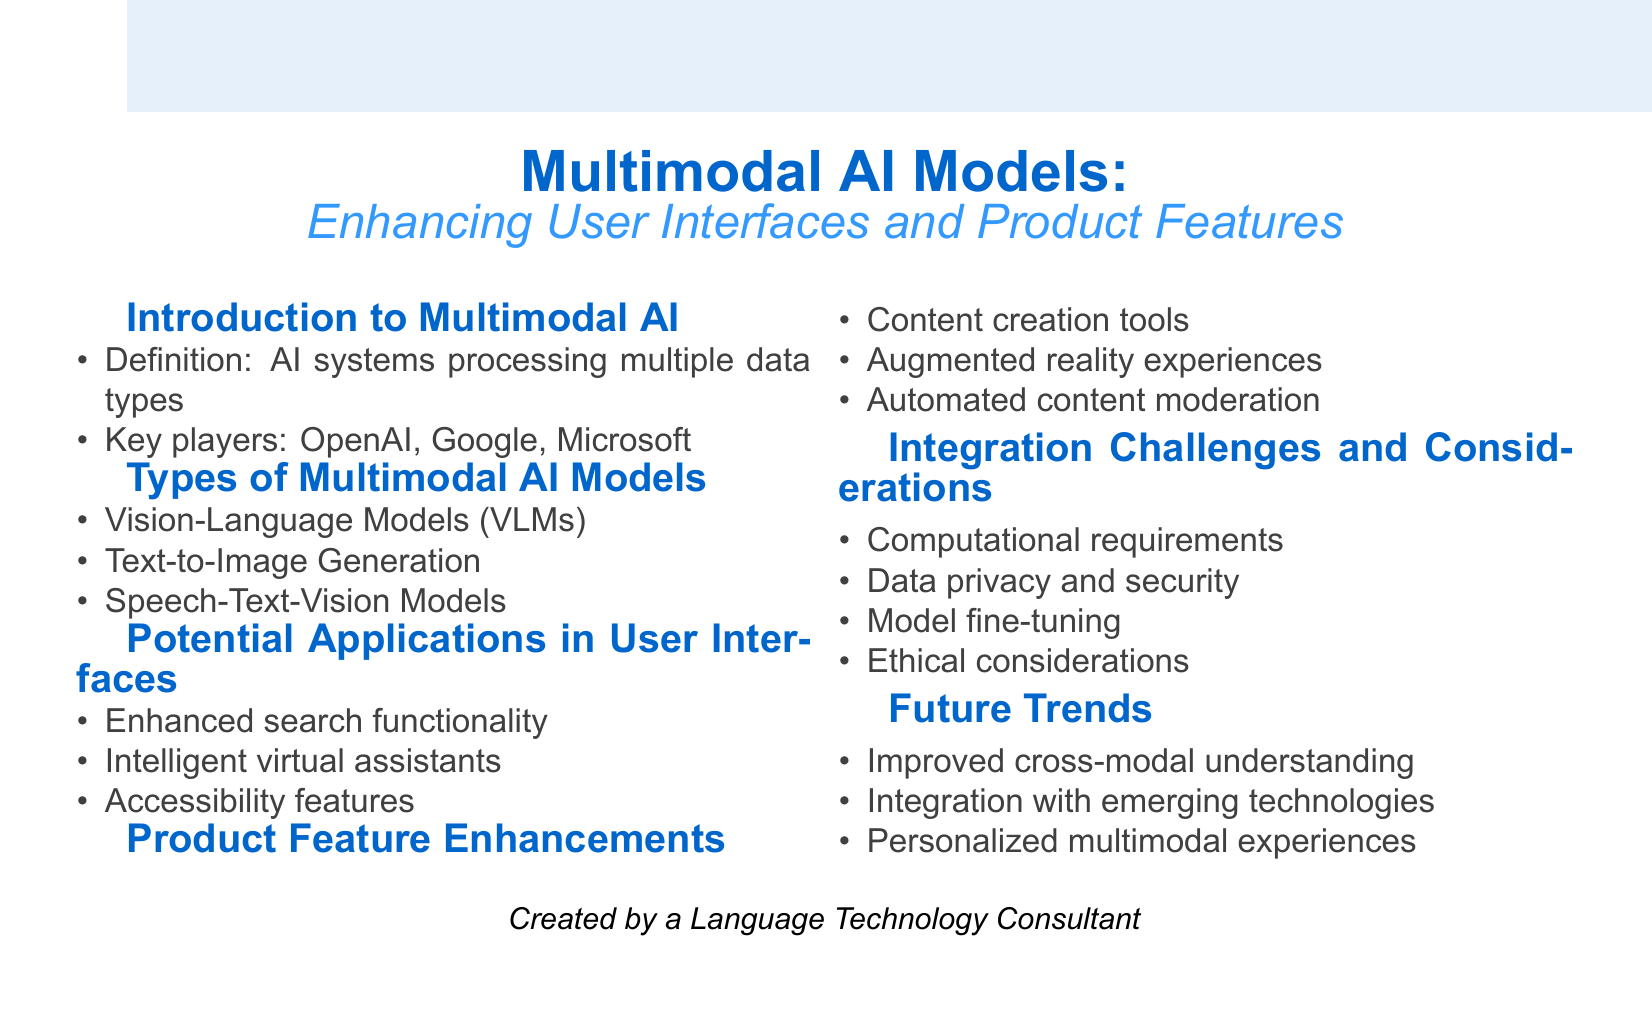What is the definition of multimodal AI? The definition states that multimodal AI refers to AI systems that can process and integrate multiple types of data.
Answer: AI systems that can process and integrate multiple types of data Who are the key players in multimodal AI? The document mentions three key players in the field of multimodal AI, namely OpenAI, Google, and Microsoft.
Answer: OpenAI, Google, Microsoft What is one example of a Vision-Language Model? The document provides CLIP and ViLT as examples under the category of Vision-Language Models.
Answer: CLIP What is a potential application of multimodal AI in user interfaces? The document lists enhanced search functionality, intelligent virtual assistants, and accessibility features as potential applications.
Answer: Enhanced search functionality Which technology is mentioned for real-time object recognition? Augmented reality experiences are highlighted for their application involving real-time object recognition and information overlay.
Answer: Augmented reality experiences What is a key challenge in integrating multimodal AI models? The document outlines several challenges, including computational requirements, data privacy and security, model fine-tuning, and ethical considerations.
Answer: Computational requirements What future trend is related to user preferences? The document mentions personalized multimodal experiences based on user preferences and behavior as a future trend.
Answer: Personalized multimodal experiences 